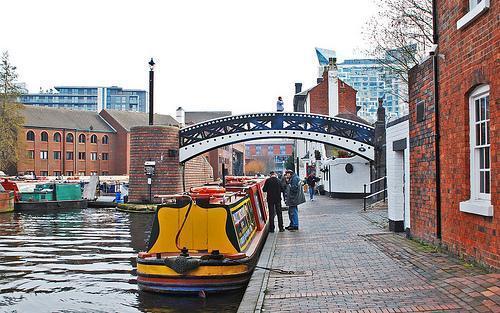How many people are near the boat?
Give a very brief answer. 2. How many bridges?
Give a very brief answer. 1. 